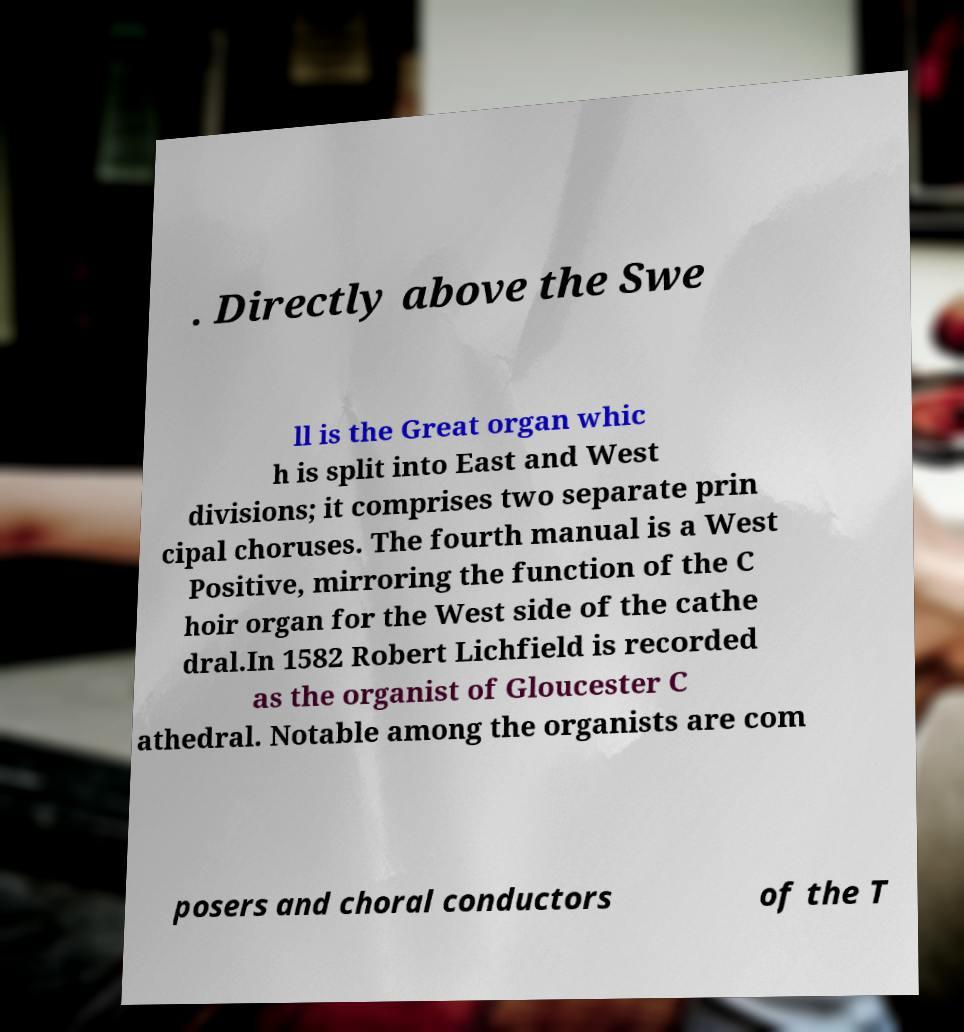Can you accurately transcribe the text from the provided image for me? . Directly above the Swe ll is the Great organ whic h is split into East and West divisions; it comprises two separate prin cipal choruses. The fourth manual is a West Positive, mirroring the function of the C hoir organ for the West side of the cathe dral.In 1582 Robert Lichfield is recorded as the organist of Gloucester C athedral. Notable among the organists are com posers and choral conductors of the T 